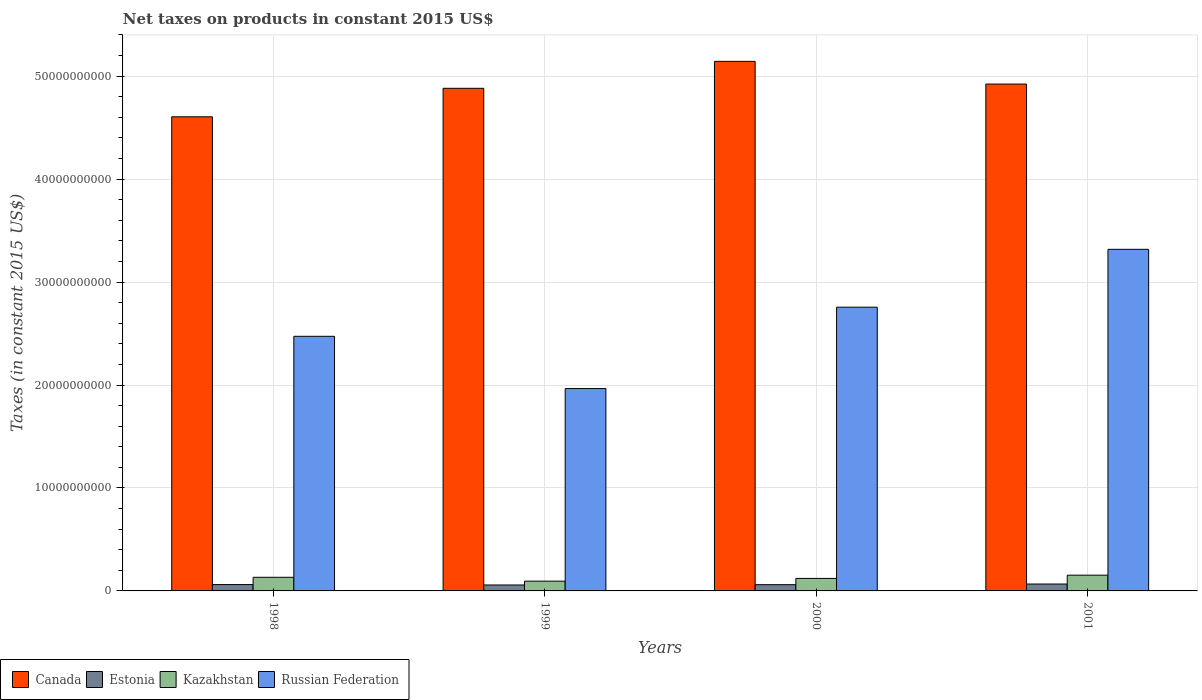How many different coloured bars are there?
Your answer should be compact. 4. What is the label of the 2nd group of bars from the left?
Offer a terse response. 1999. What is the net taxes on products in Kazakhstan in 2001?
Provide a succinct answer. 1.53e+09. Across all years, what is the maximum net taxes on products in Estonia?
Provide a succinct answer. 6.71e+08. Across all years, what is the minimum net taxes on products in Russian Federation?
Provide a short and direct response. 1.97e+1. In which year was the net taxes on products in Estonia maximum?
Give a very brief answer. 2001. In which year was the net taxes on products in Kazakhstan minimum?
Your response must be concise. 1999. What is the total net taxes on products in Kazakhstan in the graph?
Ensure brevity in your answer.  5.02e+09. What is the difference between the net taxes on products in Kazakhstan in 1998 and that in 1999?
Offer a terse response. 3.74e+08. What is the difference between the net taxes on products in Estonia in 1998 and the net taxes on products in Russian Federation in 1999?
Provide a short and direct response. -1.90e+1. What is the average net taxes on products in Estonia per year?
Ensure brevity in your answer.  6.18e+08. In the year 1998, what is the difference between the net taxes on products in Estonia and net taxes on products in Russian Federation?
Your answer should be compact. -2.41e+1. In how many years, is the net taxes on products in Estonia greater than 28000000000 US$?
Give a very brief answer. 0. What is the ratio of the net taxes on products in Kazakhstan in 1999 to that in 2000?
Your answer should be compact. 0.78. Is the difference between the net taxes on products in Estonia in 1999 and 2000 greater than the difference between the net taxes on products in Russian Federation in 1999 and 2000?
Provide a short and direct response. Yes. What is the difference between the highest and the second highest net taxes on products in Kazakhstan?
Make the answer very short. 2.07e+08. What is the difference between the highest and the lowest net taxes on products in Estonia?
Provide a succinct answer. 9.30e+07. Is it the case that in every year, the sum of the net taxes on products in Estonia and net taxes on products in Russian Federation is greater than the sum of net taxes on products in Kazakhstan and net taxes on products in Canada?
Your answer should be compact. No. What does the 1st bar from the right in 1998 represents?
Provide a succinct answer. Russian Federation. Is it the case that in every year, the sum of the net taxes on products in Canada and net taxes on products in Estonia is greater than the net taxes on products in Russian Federation?
Your answer should be compact. Yes. How many bars are there?
Keep it short and to the point. 16. Does the graph contain any zero values?
Offer a very short reply. No. How are the legend labels stacked?
Give a very brief answer. Horizontal. What is the title of the graph?
Give a very brief answer. Net taxes on products in constant 2015 US$. Does "Ukraine" appear as one of the legend labels in the graph?
Offer a very short reply. No. What is the label or title of the Y-axis?
Offer a terse response. Taxes (in constant 2015 US$). What is the Taxes (in constant 2015 US$) of Canada in 1998?
Ensure brevity in your answer.  4.60e+1. What is the Taxes (in constant 2015 US$) in Estonia in 1998?
Offer a very short reply. 6.17e+08. What is the Taxes (in constant 2015 US$) in Kazakhstan in 1998?
Offer a very short reply. 1.32e+09. What is the Taxes (in constant 2015 US$) in Russian Federation in 1998?
Ensure brevity in your answer.  2.47e+1. What is the Taxes (in constant 2015 US$) in Canada in 1999?
Give a very brief answer. 4.88e+1. What is the Taxes (in constant 2015 US$) in Estonia in 1999?
Give a very brief answer. 5.78e+08. What is the Taxes (in constant 2015 US$) in Kazakhstan in 1999?
Offer a very short reply. 9.50e+08. What is the Taxes (in constant 2015 US$) in Russian Federation in 1999?
Ensure brevity in your answer.  1.97e+1. What is the Taxes (in constant 2015 US$) of Canada in 2000?
Provide a succinct answer. 5.14e+1. What is the Taxes (in constant 2015 US$) in Estonia in 2000?
Make the answer very short. 6.06e+08. What is the Taxes (in constant 2015 US$) of Kazakhstan in 2000?
Your answer should be compact. 1.21e+09. What is the Taxes (in constant 2015 US$) in Russian Federation in 2000?
Offer a terse response. 2.76e+1. What is the Taxes (in constant 2015 US$) in Canada in 2001?
Your response must be concise. 4.92e+1. What is the Taxes (in constant 2015 US$) in Estonia in 2001?
Your answer should be compact. 6.71e+08. What is the Taxes (in constant 2015 US$) of Kazakhstan in 2001?
Offer a very short reply. 1.53e+09. What is the Taxes (in constant 2015 US$) in Russian Federation in 2001?
Make the answer very short. 3.32e+1. Across all years, what is the maximum Taxes (in constant 2015 US$) of Canada?
Provide a succinct answer. 5.14e+1. Across all years, what is the maximum Taxes (in constant 2015 US$) of Estonia?
Keep it short and to the point. 6.71e+08. Across all years, what is the maximum Taxes (in constant 2015 US$) in Kazakhstan?
Your answer should be very brief. 1.53e+09. Across all years, what is the maximum Taxes (in constant 2015 US$) of Russian Federation?
Offer a terse response. 3.32e+1. Across all years, what is the minimum Taxes (in constant 2015 US$) in Canada?
Your answer should be compact. 4.60e+1. Across all years, what is the minimum Taxes (in constant 2015 US$) in Estonia?
Your response must be concise. 5.78e+08. Across all years, what is the minimum Taxes (in constant 2015 US$) of Kazakhstan?
Provide a succinct answer. 9.50e+08. Across all years, what is the minimum Taxes (in constant 2015 US$) of Russian Federation?
Your response must be concise. 1.97e+1. What is the total Taxes (in constant 2015 US$) of Canada in the graph?
Keep it short and to the point. 1.96e+11. What is the total Taxes (in constant 2015 US$) of Estonia in the graph?
Provide a short and direct response. 2.47e+09. What is the total Taxes (in constant 2015 US$) of Kazakhstan in the graph?
Your answer should be compact. 5.02e+09. What is the total Taxes (in constant 2015 US$) in Russian Federation in the graph?
Provide a succinct answer. 1.05e+11. What is the difference between the Taxes (in constant 2015 US$) in Canada in 1998 and that in 1999?
Provide a short and direct response. -2.77e+09. What is the difference between the Taxes (in constant 2015 US$) in Estonia in 1998 and that in 1999?
Offer a terse response. 3.95e+07. What is the difference between the Taxes (in constant 2015 US$) in Kazakhstan in 1998 and that in 1999?
Keep it short and to the point. 3.74e+08. What is the difference between the Taxes (in constant 2015 US$) in Russian Federation in 1998 and that in 1999?
Offer a terse response. 5.07e+09. What is the difference between the Taxes (in constant 2015 US$) in Canada in 1998 and that in 2000?
Provide a short and direct response. -5.39e+09. What is the difference between the Taxes (in constant 2015 US$) of Estonia in 1998 and that in 2000?
Ensure brevity in your answer.  1.10e+07. What is the difference between the Taxes (in constant 2015 US$) in Kazakhstan in 1998 and that in 2000?
Provide a succinct answer. 1.09e+08. What is the difference between the Taxes (in constant 2015 US$) of Russian Federation in 1998 and that in 2000?
Provide a short and direct response. -2.83e+09. What is the difference between the Taxes (in constant 2015 US$) in Canada in 1998 and that in 2001?
Your answer should be very brief. -3.18e+09. What is the difference between the Taxes (in constant 2015 US$) of Estonia in 1998 and that in 2001?
Offer a very short reply. -5.35e+07. What is the difference between the Taxes (in constant 2015 US$) in Kazakhstan in 1998 and that in 2001?
Your response must be concise. -2.07e+08. What is the difference between the Taxes (in constant 2015 US$) in Russian Federation in 1998 and that in 2001?
Keep it short and to the point. -8.45e+09. What is the difference between the Taxes (in constant 2015 US$) in Canada in 1999 and that in 2000?
Your answer should be very brief. -2.62e+09. What is the difference between the Taxes (in constant 2015 US$) in Estonia in 1999 and that in 2000?
Provide a succinct answer. -2.85e+07. What is the difference between the Taxes (in constant 2015 US$) of Kazakhstan in 1999 and that in 2000?
Ensure brevity in your answer.  -2.65e+08. What is the difference between the Taxes (in constant 2015 US$) of Russian Federation in 1999 and that in 2000?
Offer a terse response. -7.90e+09. What is the difference between the Taxes (in constant 2015 US$) in Canada in 1999 and that in 2001?
Ensure brevity in your answer.  -4.14e+08. What is the difference between the Taxes (in constant 2015 US$) of Estonia in 1999 and that in 2001?
Ensure brevity in your answer.  -9.30e+07. What is the difference between the Taxes (in constant 2015 US$) in Kazakhstan in 1999 and that in 2001?
Give a very brief answer. -5.81e+08. What is the difference between the Taxes (in constant 2015 US$) of Russian Federation in 1999 and that in 2001?
Provide a short and direct response. -1.35e+1. What is the difference between the Taxes (in constant 2015 US$) in Canada in 2000 and that in 2001?
Your answer should be very brief. 2.20e+09. What is the difference between the Taxes (in constant 2015 US$) of Estonia in 2000 and that in 2001?
Offer a terse response. -6.45e+07. What is the difference between the Taxes (in constant 2015 US$) of Kazakhstan in 2000 and that in 2001?
Offer a terse response. -3.16e+08. What is the difference between the Taxes (in constant 2015 US$) in Russian Federation in 2000 and that in 2001?
Give a very brief answer. -5.62e+09. What is the difference between the Taxes (in constant 2015 US$) of Canada in 1998 and the Taxes (in constant 2015 US$) of Estonia in 1999?
Ensure brevity in your answer.  4.55e+1. What is the difference between the Taxes (in constant 2015 US$) of Canada in 1998 and the Taxes (in constant 2015 US$) of Kazakhstan in 1999?
Your answer should be very brief. 4.51e+1. What is the difference between the Taxes (in constant 2015 US$) of Canada in 1998 and the Taxes (in constant 2015 US$) of Russian Federation in 1999?
Your answer should be compact. 2.64e+1. What is the difference between the Taxes (in constant 2015 US$) in Estonia in 1998 and the Taxes (in constant 2015 US$) in Kazakhstan in 1999?
Provide a short and direct response. -3.33e+08. What is the difference between the Taxes (in constant 2015 US$) in Estonia in 1998 and the Taxes (in constant 2015 US$) in Russian Federation in 1999?
Keep it short and to the point. -1.90e+1. What is the difference between the Taxes (in constant 2015 US$) in Kazakhstan in 1998 and the Taxes (in constant 2015 US$) in Russian Federation in 1999?
Your answer should be very brief. -1.83e+1. What is the difference between the Taxes (in constant 2015 US$) in Canada in 1998 and the Taxes (in constant 2015 US$) in Estonia in 2000?
Offer a very short reply. 4.54e+1. What is the difference between the Taxes (in constant 2015 US$) in Canada in 1998 and the Taxes (in constant 2015 US$) in Kazakhstan in 2000?
Your answer should be very brief. 4.48e+1. What is the difference between the Taxes (in constant 2015 US$) of Canada in 1998 and the Taxes (in constant 2015 US$) of Russian Federation in 2000?
Ensure brevity in your answer.  1.85e+1. What is the difference between the Taxes (in constant 2015 US$) in Estonia in 1998 and the Taxes (in constant 2015 US$) in Kazakhstan in 2000?
Ensure brevity in your answer.  -5.98e+08. What is the difference between the Taxes (in constant 2015 US$) of Estonia in 1998 and the Taxes (in constant 2015 US$) of Russian Federation in 2000?
Provide a succinct answer. -2.69e+1. What is the difference between the Taxes (in constant 2015 US$) in Kazakhstan in 1998 and the Taxes (in constant 2015 US$) in Russian Federation in 2000?
Offer a very short reply. -2.62e+1. What is the difference between the Taxes (in constant 2015 US$) of Canada in 1998 and the Taxes (in constant 2015 US$) of Estonia in 2001?
Your answer should be very brief. 4.54e+1. What is the difference between the Taxes (in constant 2015 US$) in Canada in 1998 and the Taxes (in constant 2015 US$) in Kazakhstan in 2001?
Provide a succinct answer. 4.45e+1. What is the difference between the Taxes (in constant 2015 US$) of Canada in 1998 and the Taxes (in constant 2015 US$) of Russian Federation in 2001?
Provide a succinct answer. 1.29e+1. What is the difference between the Taxes (in constant 2015 US$) of Estonia in 1998 and the Taxes (in constant 2015 US$) of Kazakhstan in 2001?
Ensure brevity in your answer.  -9.14e+08. What is the difference between the Taxes (in constant 2015 US$) of Estonia in 1998 and the Taxes (in constant 2015 US$) of Russian Federation in 2001?
Ensure brevity in your answer.  -3.26e+1. What is the difference between the Taxes (in constant 2015 US$) of Kazakhstan in 1998 and the Taxes (in constant 2015 US$) of Russian Federation in 2001?
Make the answer very short. -3.19e+1. What is the difference between the Taxes (in constant 2015 US$) in Canada in 1999 and the Taxes (in constant 2015 US$) in Estonia in 2000?
Provide a succinct answer. 4.82e+1. What is the difference between the Taxes (in constant 2015 US$) in Canada in 1999 and the Taxes (in constant 2015 US$) in Kazakhstan in 2000?
Your answer should be compact. 4.76e+1. What is the difference between the Taxes (in constant 2015 US$) in Canada in 1999 and the Taxes (in constant 2015 US$) in Russian Federation in 2000?
Give a very brief answer. 2.13e+1. What is the difference between the Taxes (in constant 2015 US$) of Estonia in 1999 and the Taxes (in constant 2015 US$) of Kazakhstan in 2000?
Provide a short and direct response. -6.37e+08. What is the difference between the Taxes (in constant 2015 US$) in Estonia in 1999 and the Taxes (in constant 2015 US$) in Russian Federation in 2000?
Your response must be concise. -2.70e+1. What is the difference between the Taxes (in constant 2015 US$) in Kazakhstan in 1999 and the Taxes (in constant 2015 US$) in Russian Federation in 2000?
Ensure brevity in your answer.  -2.66e+1. What is the difference between the Taxes (in constant 2015 US$) of Canada in 1999 and the Taxes (in constant 2015 US$) of Estonia in 2001?
Offer a very short reply. 4.81e+1. What is the difference between the Taxes (in constant 2015 US$) in Canada in 1999 and the Taxes (in constant 2015 US$) in Kazakhstan in 2001?
Your answer should be compact. 4.73e+1. What is the difference between the Taxes (in constant 2015 US$) of Canada in 1999 and the Taxes (in constant 2015 US$) of Russian Federation in 2001?
Provide a succinct answer. 1.56e+1. What is the difference between the Taxes (in constant 2015 US$) in Estonia in 1999 and the Taxes (in constant 2015 US$) in Kazakhstan in 2001?
Your answer should be very brief. -9.53e+08. What is the difference between the Taxes (in constant 2015 US$) in Estonia in 1999 and the Taxes (in constant 2015 US$) in Russian Federation in 2001?
Give a very brief answer. -3.26e+1. What is the difference between the Taxes (in constant 2015 US$) of Kazakhstan in 1999 and the Taxes (in constant 2015 US$) of Russian Federation in 2001?
Ensure brevity in your answer.  -3.22e+1. What is the difference between the Taxes (in constant 2015 US$) in Canada in 2000 and the Taxes (in constant 2015 US$) in Estonia in 2001?
Make the answer very short. 5.08e+1. What is the difference between the Taxes (in constant 2015 US$) in Canada in 2000 and the Taxes (in constant 2015 US$) in Kazakhstan in 2001?
Offer a terse response. 4.99e+1. What is the difference between the Taxes (in constant 2015 US$) of Canada in 2000 and the Taxes (in constant 2015 US$) of Russian Federation in 2001?
Your response must be concise. 1.83e+1. What is the difference between the Taxes (in constant 2015 US$) in Estonia in 2000 and the Taxes (in constant 2015 US$) in Kazakhstan in 2001?
Provide a succinct answer. -9.25e+08. What is the difference between the Taxes (in constant 2015 US$) of Estonia in 2000 and the Taxes (in constant 2015 US$) of Russian Federation in 2001?
Keep it short and to the point. -3.26e+1. What is the difference between the Taxes (in constant 2015 US$) of Kazakhstan in 2000 and the Taxes (in constant 2015 US$) of Russian Federation in 2001?
Your response must be concise. -3.20e+1. What is the average Taxes (in constant 2015 US$) in Canada per year?
Offer a very short reply. 4.89e+1. What is the average Taxes (in constant 2015 US$) in Estonia per year?
Your answer should be compact. 6.18e+08. What is the average Taxes (in constant 2015 US$) of Kazakhstan per year?
Offer a very short reply. 1.25e+09. What is the average Taxes (in constant 2015 US$) in Russian Federation per year?
Offer a terse response. 2.63e+1. In the year 1998, what is the difference between the Taxes (in constant 2015 US$) in Canada and Taxes (in constant 2015 US$) in Estonia?
Keep it short and to the point. 4.54e+1. In the year 1998, what is the difference between the Taxes (in constant 2015 US$) in Canada and Taxes (in constant 2015 US$) in Kazakhstan?
Make the answer very short. 4.47e+1. In the year 1998, what is the difference between the Taxes (in constant 2015 US$) of Canada and Taxes (in constant 2015 US$) of Russian Federation?
Offer a very short reply. 2.13e+1. In the year 1998, what is the difference between the Taxes (in constant 2015 US$) of Estonia and Taxes (in constant 2015 US$) of Kazakhstan?
Your answer should be compact. -7.07e+08. In the year 1998, what is the difference between the Taxes (in constant 2015 US$) of Estonia and Taxes (in constant 2015 US$) of Russian Federation?
Provide a short and direct response. -2.41e+1. In the year 1998, what is the difference between the Taxes (in constant 2015 US$) in Kazakhstan and Taxes (in constant 2015 US$) in Russian Federation?
Provide a succinct answer. -2.34e+1. In the year 1999, what is the difference between the Taxes (in constant 2015 US$) in Canada and Taxes (in constant 2015 US$) in Estonia?
Your answer should be very brief. 4.82e+1. In the year 1999, what is the difference between the Taxes (in constant 2015 US$) of Canada and Taxes (in constant 2015 US$) of Kazakhstan?
Offer a terse response. 4.79e+1. In the year 1999, what is the difference between the Taxes (in constant 2015 US$) in Canada and Taxes (in constant 2015 US$) in Russian Federation?
Ensure brevity in your answer.  2.92e+1. In the year 1999, what is the difference between the Taxes (in constant 2015 US$) in Estonia and Taxes (in constant 2015 US$) in Kazakhstan?
Your answer should be very brief. -3.72e+08. In the year 1999, what is the difference between the Taxes (in constant 2015 US$) of Estonia and Taxes (in constant 2015 US$) of Russian Federation?
Provide a succinct answer. -1.91e+1. In the year 1999, what is the difference between the Taxes (in constant 2015 US$) in Kazakhstan and Taxes (in constant 2015 US$) in Russian Federation?
Offer a very short reply. -1.87e+1. In the year 2000, what is the difference between the Taxes (in constant 2015 US$) in Canada and Taxes (in constant 2015 US$) in Estonia?
Give a very brief answer. 5.08e+1. In the year 2000, what is the difference between the Taxes (in constant 2015 US$) of Canada and Taxes (in constant 2015 US$) of Kazakhstan?
Provide a succinct answer. 5.02e+1. In the year 2000, what is the difference between the Taxes (in constant 2015 US$) in Canada and Taxes (in constant 2015 US$) in Russian Federation?
Your response must be concise. 2.39e+1. In the year 2000, what is the difference between the Taxes (in constant 2015 US$) of Estonia and Taxes (in constant 2015 US$) of Kazakhstan?
Make the answer very short. -6.09e+08. In the year 2000, what is the difference between the Taxes (in constant 2015 US$) of Estonia and Taxes (in constant 2015 US$) of Russian Federation?
Your answer should be compact. -2.70e+1. In the year 2000, what is the difference between the Taxes (in constant 2015 US$) of Kazakhstan and Taxes (in constant 2015 US$) of Russian Federation?
Offer a terse response. -2.63e+1. In the year 2001, what is the difference between the Taxes (in constant 2015 US$) in Canada and Taxes (in constant 2015 US$) in Estonia?
Provide a short and direct response. 4.86e+1. In the year 2001, what is the difference between the Taxes (in constant 2015 US$) of Canada and Taxes (in constant 2015 US$) of Kazakhstan?
Make the answer very short. 4.77e+1. In the year 2001, what is the difference between the Taxes (in constant 2015 US$) in Canada and Taxes (in constant 2015 US$) in Russian Federation?
Make the answer very short. 1.61e+1. In the year 2001, what is the difference between the Taxes (in constant 2015 US$) in Estonia and Taxes (in constant 2015 US$) in Kazakhstan?
Provide a short and direct response. -8.60e+08. In the year 2001, what is the difference between the Taxes (in constant 2015 US$) of Estonia and Taxes (in constant 2015 US$) of Russian Federation?
Keep it short and to the point. -3.25e+1. In the year 2001, what is the difference between the Taxes (in constant 2015 US$) of Kazakhstan and Taxes (in constant 2015 US$) of Russian Federation?
Provide a short and direct response. -3.16e+1. What is the ratio of the Taxes (in constant 2015 US$) of Canada in 1998 to that in 1999?
Make the answer very short. 0.94. What is the ratio of the Taxes (in constant 2015 US$) in Estonia in 1998 to that in 1999?
Keep it short and to the point. 1.07. What is the ratio of the Taxes (in constant 2015 US$) of Kazakhstan in 1998 to that in 1999?
Offer a terse response. 1.39. What is the ratio of the Taxes (in constant 2015 US$) of Russian Federation in 1998 to that in 1999?
Provide a short and direct response. 1.26. What is the ratio of the Taxes (in constant 2015 US$) in Canada in 1998 to that in 2000?
Keep it short and to the point. 0.9. What is the ratio of the Taxes (in constant 2015 US$) of Estonia in 1998 to that in 2000?
Provide a short and direct response. 1.02. What is the ratio of the Taxes (in constant 2015 US$) in Kazakhstan in 1998 to that in 2000?
Your response must be concise. 1.09. What is the ratio of the Taxes (in constant 2015 US$) of Russian Federation in 1998 to that in 2000?
Make the answer very short. 0.9. What is the ratio of the Taxes (in constant 2015 US$) of Canada in 1998 to that in 2001?
Provide a short and direct response. 0.94. What is the ratio of the Taxes (in constant 2015 US$) of Estonia in 1998 to that in 2001?
Give a very brief answer. 0.92. What is the ratio of the Taxes (in constant 2015 US$) of Kazakhstan in 1998 to that in 2001?
Your answer should be compact. 0.86. What is the ratio of the Taxes (in constant 2015 US$) in Russian Federation in 1998 to that in 2001?
Give a very brief answer. 0.75. What is the ratio of the Taxes (in constant 2015 US$) of Canada in 1999 to that in 2000?
Provide a succinct answer. 0.95. What is the ratio of the Taxes (in constant 2015 US$) in Estonia in 1999 to that in 2000?
Your answer should be very brief. 0.95. What is the ratio of the Taxes (in constant 2015 US$) in Kazakhstan in 1999 to that in 2000?
Provide a short and direct response. 0.78. What is the ratio of the Taxes (in constant 2015 US$) of Russian Federation in 1999 to that in 2000?
Your response must be concise. 0.71. What is the ratio of the Taxes (in constant 2015 US$) of Estonia in 1999 to that in 2001?
Your answer should be very brief. 0.86. What is the ratio of the Taxes (in constant 2015 US$) in Kazakhstan in 1999 to that in 2001?
Your response must be concise. 0.62. What is the ratio of the Taxes (in constant 2015 US$) of Russian Federation in 1999 to that in 2001?
Give a very brief answer. 0.59. What is the ratio of the Taxes (in constant 2015 US$) in Canada in 2000 to that in 2001?
Make the answer very short. 1.04. What is the ratio of the Taxes (in constant 2015 US$) in Estonia in 2000 to that in 2001?
Your answer should be very brief. 0.9. What is the ratio of the Taxes (in constant 2015 US$) of Kazakhstan in 2000 to that in 2001?
Provide a short and direct response. 0.79. What is the ratio of the Taxes (in constant 2015 US$) in Russian Federation in 2000 to that in 2001?
Offer a terse response. 0.83. What is the difference between the highest and the second highest Taxes (in constant 2015 US$) in Canada?
Make the answer very short. 2.20e+09. What is the difference between the highest and the second highest Taxes (in constant 2015 US$) in Estonia?
Your answer should be very brief. 5.35e+07. What is the difference between the highest and the second highest Taxes (in constant 2015 US$) in Kazakhstan?
Offer a terse response. 2.07e+08. What is the difference between the highest and the second highest Taxes (in constant 2015 US$) in Russian Federation?
Offer a terse response. 5.62e+09. What is the difference between the highest and the lowest Taxes (in constant 2015 US$) in Canada?
Make the answer very short. 5.39e+09. What is the difference between the highest and the lowest Taxes (in constant 2015 US$) of Estonia?
Your response must be concise. 9.30e+07. What is the difference between the highest and the lowest Taxes (in constant 2015 US$) of Kazakhstan?
Ensure brevity in your answer.  5.81e+08. What is the difference between the highest and the lowest Taxes (in constant 2015 US$) of Russian Federation?
Provide a succinct answer. 1.35e+1. 